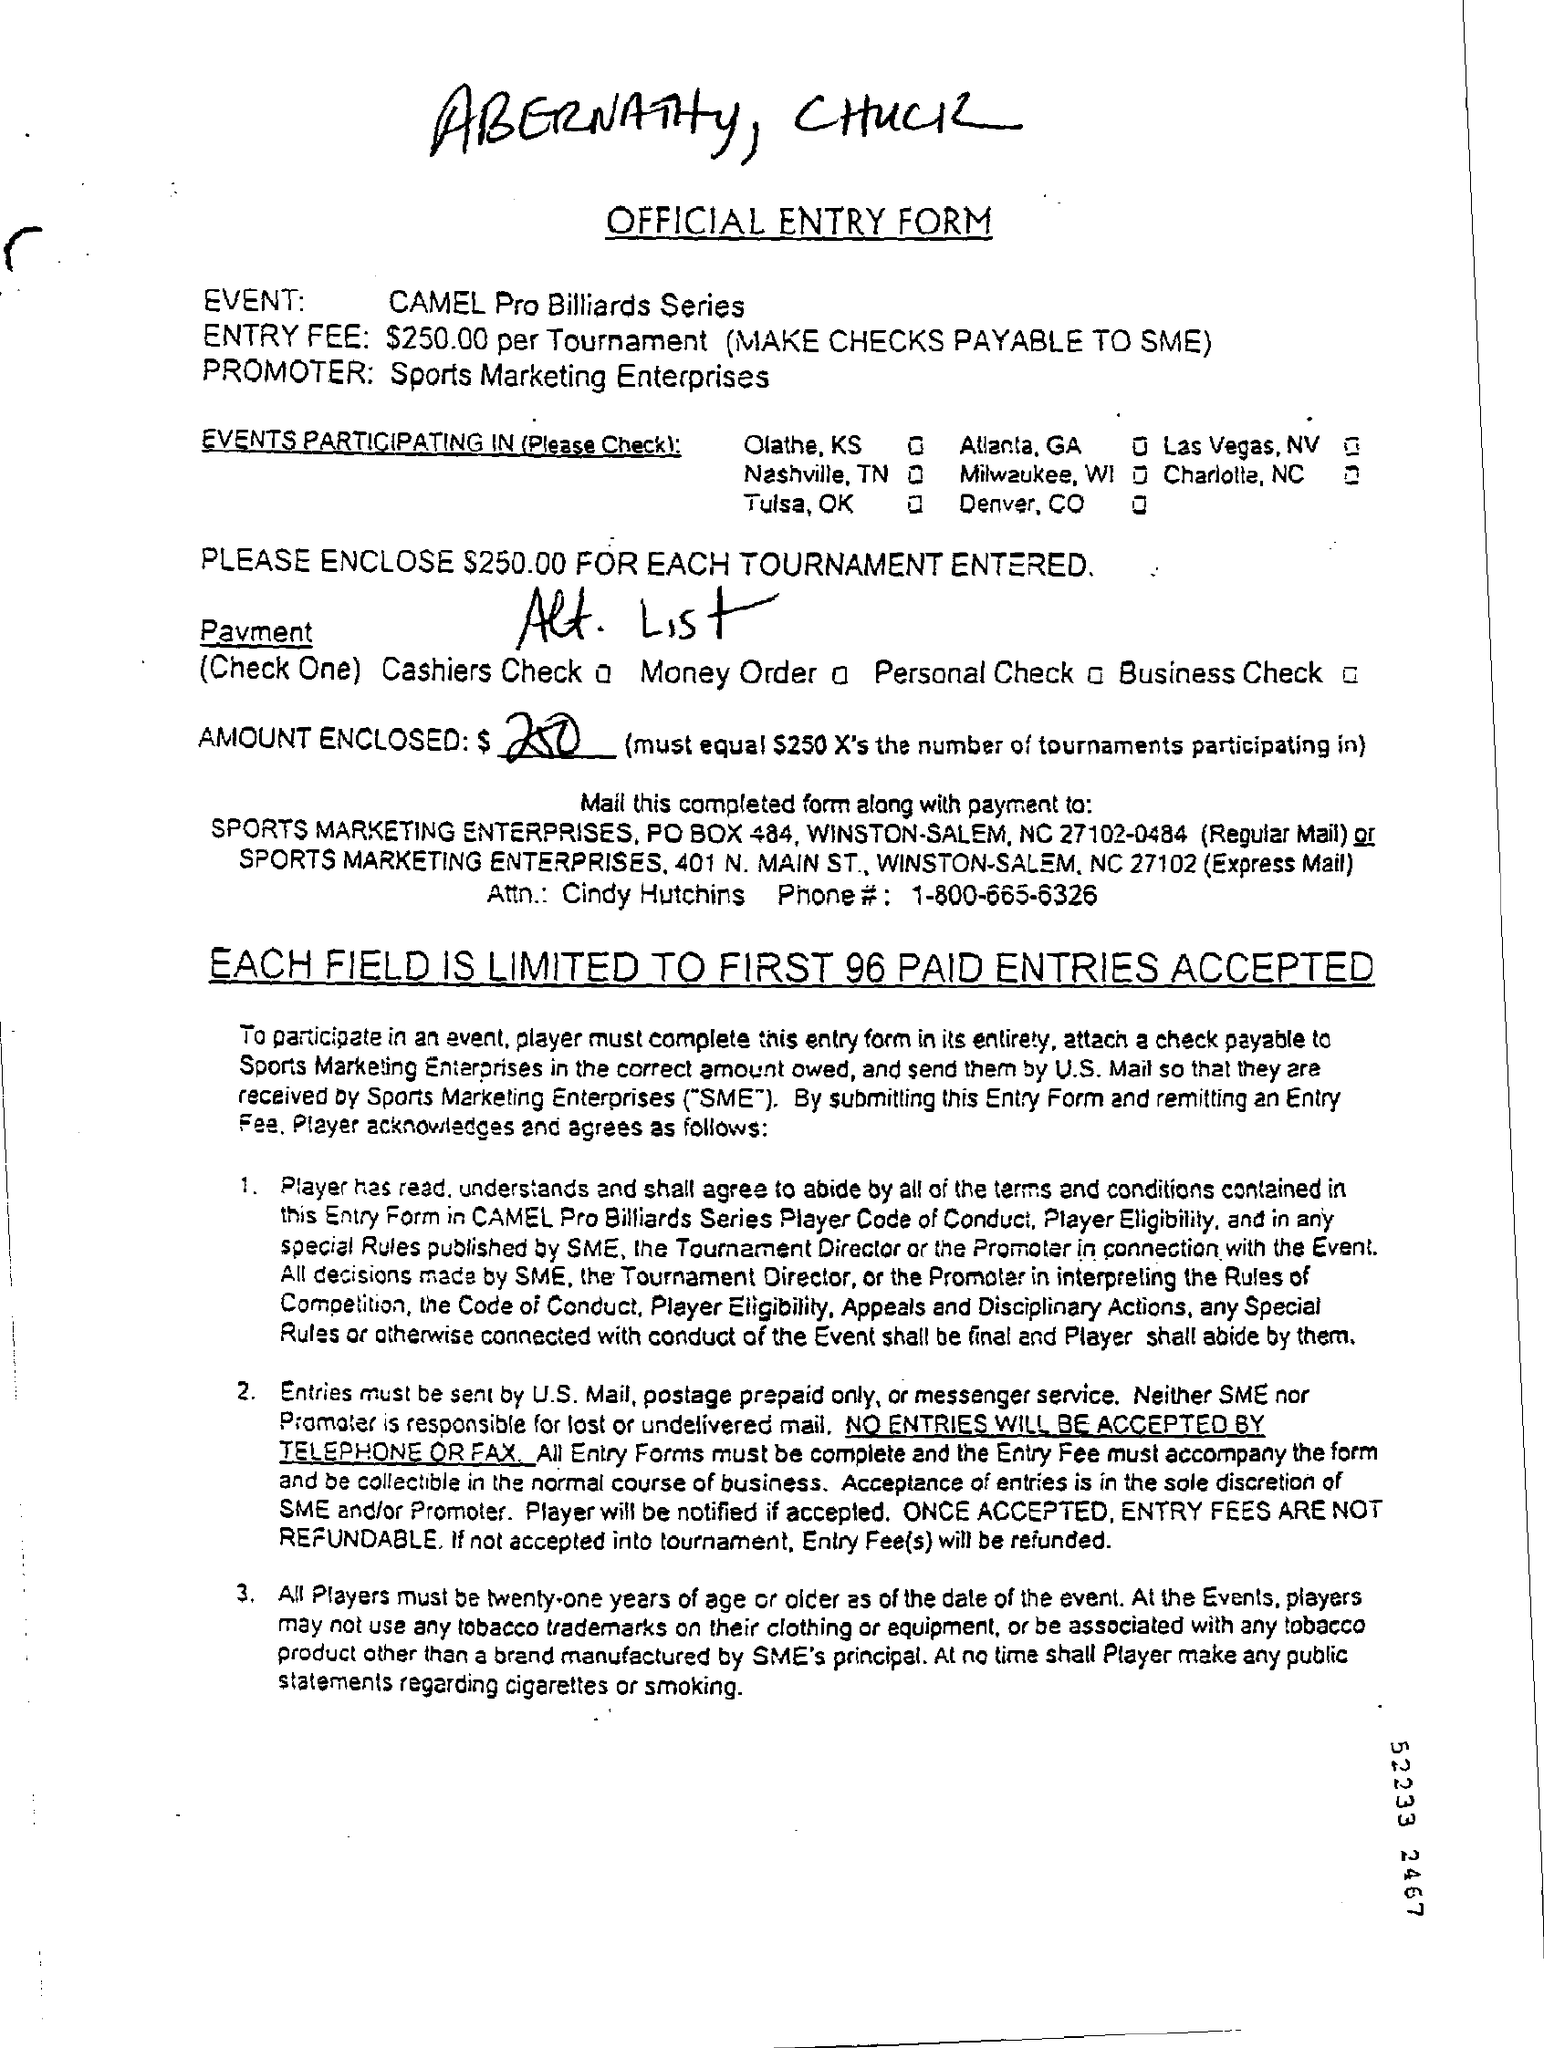What is the form about?
Offer a terse response. OFFICIAL ENTRY FORM. What is the event?
Ensure brevity in your answer.  CAMEL Pro Billiards Series. What is the entry fee?
Your answer should be very brief. $250.00. Who is the promoter?
Provide a short and direct response. Sports Marketing Enterprises. Will entries be accepted by telephone or fax?
Your response must be concise. No. 